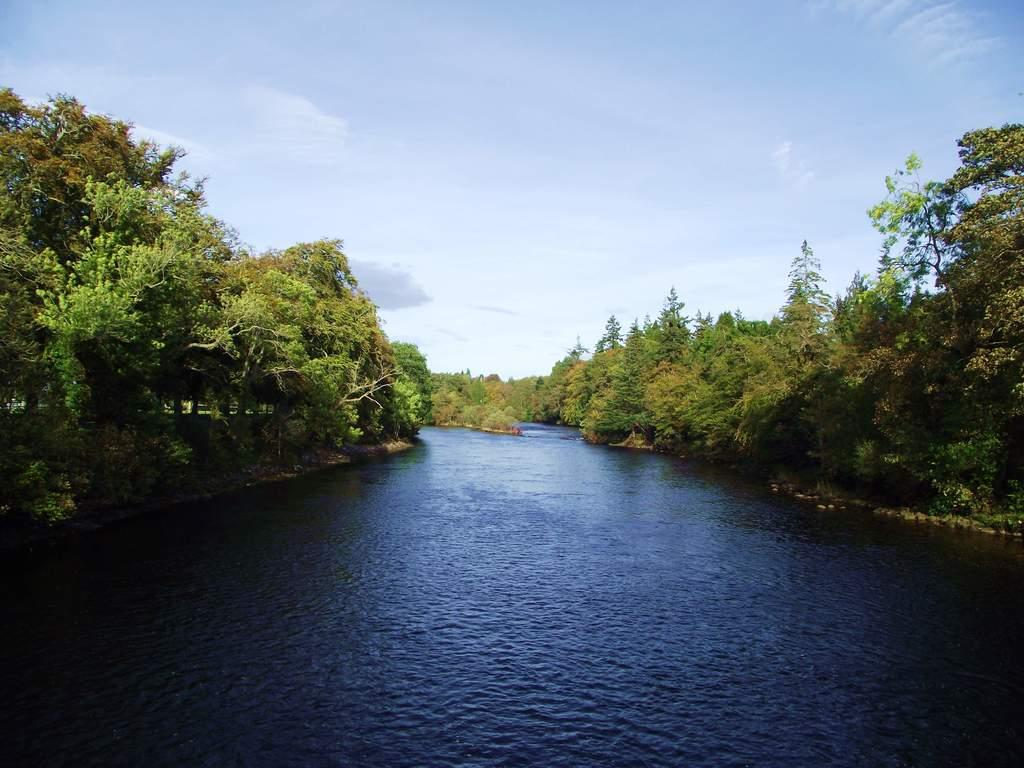What is located in the middle of the image? There is water in the middle of the image. What can be seen on either side of the water? There are trees on either side of the water. What is visible at the top of the image? The sky is visible at the top of the image. How would you describe the weather based on the sky? The sky appears to be sunny, suggesting good weather. What type of shoe can be seen flying in the image? There is no shoe present in the image, let alone one that is flying. 